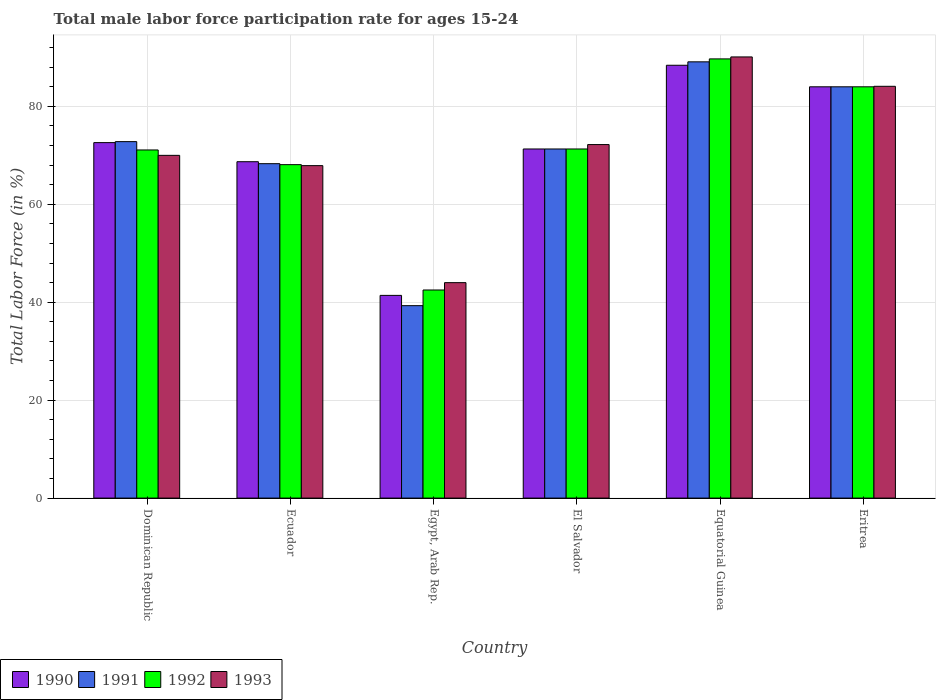How many different coloured bars are there?
Make the answer very short. 4. Are the number of bars per tick equal to the number of legend labels?
Offer a terse response. Yes. How many bars are there on the 3rd tick from the right?
Your answer should be very brief. 4. What is the label of the 6th group of bars from the left?
Your response must be concise. Eritrea. What is the male labor force participation rate in 1990 in El Salvador?
Ensure brevity in your answer.  71.3. Across all countries, what is the maximum male labor force participation rate in 1990?
Your answer should be very brief. 88.4. In which country was the male labor force participation rate in 1990 maximum?
Your answer should be compact. Equatorial Guinea. In which country was the male labor force participation rate in 1991 minimum?
Provide a succinct answer. Egypt, Arab Rep. What is the total male labor force participation rate in 1992 in the graph?
Your answer should be very brief. 426.7. What is the difference between the male labor force participation rate in 1990 in El Salvador and that in Eritrea?
Make the answer very short. -12.7. What is the average male labor force participation rate in 1991 per country?
Offer a terse response. 70.8. What is the difference between the male labor force participation rate of/in 1993 and male labor force participation rate of/in 1992 in Dominican Republic?
Offer a terse response. -1.1. What is the ratio of the male labor force participation rate in 1991 in Dominican Republic to that in El Salvador?
Your answer should be very brief. 1.02. Is the difference between the male labor force participation rate in 1993 in Dominican Republic and El Salvador greater than the difference between the male labor force participation rate in 1992 in Dominican Republic and El Salvador?
Ensure brevity in your answer.  No. What is the difference between the highest and the second highest male labor force participation rate in 1991?
Provide a short and direct response. -16.3. What is the difference between the highest and the lowest male labor force participation rate in 1992?
Your answer should be very brief. 47.2. In how many countries, is the male labor force participation rate in 1990 greater than the average male labor force participation rate in 1990 taken over all countries?
Your response must be concise. 4. Is it the case that in every country, the sum of the male labor force participation rate in 1993 and male labor force participation rate in 1992 is greater than the sum of male labor force participation rate in 1991 and male labor force participation rate in 1990?
Give a very brief answer. No. What does the 3rd bar from the right in Dominican Republic represents?
Offer a very short reply. 1991. Is it the case that in every country, the sum of the male labor force participation rate in 1992 and male labor force participation rate in 1993 is greater than the male labor force participation rate in 1991?
Your response must be concise. Yes. How many bars are there?
Give a very brief answer. 24. What is the difference between two consecutive major ticks on the Y-axis?
Provide a short and direct response. 20. Are the values on the major ticks of Y-axis written in scientific E-notation?
Make the answer very short. No. Does the graph contain grids?
Provide a short and direct response. Yes. Where does the legend appear in the graph?
Your response must be concise. Bottom left. How many legend labels are there?
Offer a terse response. 4. What is the title of the graph?
Give a very brief answer. Total male labor force participation rate for ages 15-24. Does "2013" appear as one of the legend labels in the graph?
Provide a short and direct response. No. What is the Total Labor Force (in %) in 1990 in Dominican Republic?
Provide a succinct answer. 72.6. What is the Total Labor Force (in %) of 1991 in Dominican Republic?
Keep it short and to the point. 72.8. What is the Total Labor Force (in %) of 1992 in Dominican Republic?
Provide a succinct answer. 71.1. What is the Total Labor Force (in %) in 1990 in Ecuador?
Ensure brevity in your answer.  68.7. What is the Total Labor Force (in %) in 1991 in Ecuador?
Provide a short and direct response. 68.3. What is the Total Labor Force (in %) in 1992 in Ecuador?
Offer a very short reply. 68.1. What is the Total Labor Force (in %) in 1993 in Ecuador?
Provide a short and direct response. 67.9. What is the Total Labor Force (in %) in 1990 in Egypt, Arab Rep.?
Provide a succinct answer. 41.4. What is the Total Labor Force (in %) of 1991 in Egypt, Arab Rep.?
Offer a terse response. 39.3. What is the Total Labor Force (in %) of 1992 in Egypt, Arab Rep.?
Offer a very short reply. 42.5. What is the Total Labor Force (in %) of 1993 in Egypt, Arab Rep.?
Keep it short and to the point. 44. What is the Total Labor Force (in %) of 1990 in El Salvador?
Offer a very short reply. 71.3. What is the Total Labor Force (in %) in 1991 in El Salvador?
Ensure brevity in your answer.  71.3. What is the Total Labor Force (in %) in 1992 in El Salvador?
Offer a very short reply. 71.3. What is the Total Labor Force (in %) in 1993 in El Salvador?
Your answer should be compact. 72.2. What is the Total Labor Force (in %) in 1990 in Equatorial Guinea?
Your response must be concise. 88.4. What is the Total Labor Force (in %) of 1991 in Equatorial Guinea?
Your response must be concise. 89.1. What is the Total Labor Force (in %) of 1992 in Equatorial Guinea?
Your answer should be very brief. 89.7. What is the Total Labor Force (in %) in 1993 in Equatorial Guinea?
Your answer should be very brief. 90.1. What is the Total Labor Force (in %) in 1991 in Eritrea?
Your answer should be very brief. 84. What is the Total Labor Force (in %) in 1993 in Eritrea?
Your answer should be compact. 84.1. Across all countries, what is the maximum Total Labor Force (in %) in 1990?
Give a very brief answer. 88.4. Across all countries, what is the maximum Total Labor Force (in %) of 1991?
Your response must be concise. 89.1. Across all countries, what is the maximum Total Labor Force (in %) in 1992?
Keep it short and to the point. 89.7. Across all countries, what is the maximum Total Labor Force (in %) in 1993?
Your answer should be compact. 90.1. Across all countries, what is the minimum Total Labor Force (in %) in 1990?
Provide a short and direct response. 41.4. Across all countries, what is the minimum Total Labor Force (in %) in 1991?
Provide a succinct answer. 39.3. Across all countries, what is the minimum Total Labor Force (in %) in 1992?
Your answer should be very brief. 42.5. What is the total Total Labor Force (in %) of 1990 in the graph?
Keep it short and to the point. 426.4. What is the total Total Labor Force (in %) in 1991 in the graph?
Provide a succinct answer. 424.8. What is the total Total Labor Force (in %) of 1992 in the graph?
Ensure brevity in your answer.  426.7. What is the total Total Labor Force (in %) of 1993 in the graph?
Your answer should be compact. 428.3. What is the difference between the Total Labor Force (in %) in 1990 in Dominican Republic and that in Ecuador?
Give a very brief answer. 3.9. What is the difference between the Total Labor Force (in %) in 1990 in Dominican Republic and that in Egypt, Arab Rep.?
Provide a succinct answer. 31.2. What is the difference between the Total Labor Force (in %) in 1991 in Dominican Republic and that in Egypt, Arab Rep.?
Provide a short and direct response. 33.5. What is the difference between the Total Labor Force (in %) in 1992 in Dominican Republic and that in Egypt, Arab Rep.?
Keep it short and to the point. 28.6. What is the difference between the Total Labor Force (in %) in 1993 in Dominican Republic and that in Egypt, Arab Rep.?
Provide a succinct answer. 26. What is the difference between the Total Labor Force (in %) of 1990 in Dominican Republic and that in El Salvador?
Keep it short and to the point. 1.3. What is the difference between the Total Labor Force (in %) of 1992 in Dominican Republic and that in El Salvador?
Ensure brevity in your answer.  -0.2. What is the difference between the Total Labor Force (in %) in 1990 in Dominican Republic and that in Equatorial Guinea?
Your answer should be compact. -15.8. What is the difference between the Total Labor Force (in %) of 1991 in Dominican Republic and that in Equatorial Guinea?
Ensure brevity in your answer.  -16.3. What is the difference between the Total Labor Force (in %) in 1992 in Dominican Republic and that in Equatorial Guinea?
Offer a very short reply. -18.6. What is the difference between the Total Labor Force (in %) in 1993 in Dominican Republic and that in Equatorial Guinea?
Your answer should be very brief. -20.1. What is the difference between the Total Labor Force (in %) of 1991 in Dominican Republic and that in Eritrea?
Give a very brief answer. -11.2. What is the difference between the Total Labor Force (in %) of 1993 in Dominican Republic and that in Eritrea?
Your answer should be compact. -14.1. What is the difference between the Total Labor Force (in %) in 1990 in Ecuador and that in Egypt, Arab Rep.?
Your response must be concise. 27.3. What is the difference between the Total Labor Force (in %) in 1992 in Ecuador and that in Egypt, Arab Rep.?
Make the answer very short. 25.6. What is the difference between the Total Labor Force (in %) in 1993 in Ecuador and that in Egypt, Arab Rep.?
Ensure brevity in your answer.  23.9. What is the difference between the Total Labor Force (in %) of 1991 in Ecuador and that in El Salvador?
Give a very brief answer. -3. What is the difference between the Total Labor Force (in %) in 1993 in Ecuador and that in El Salvador?
Give a very brief answer. -4.3. What is the difference between the Total Labor Force (in %) of 1990 in Ecuador and that in Equatorial Guinea?
Your answer should be very brief. -19.7. What is the difference between the Total Labor Force (in %) in 1991 in Ecuador and that in Equatorial Guinea?
Offer a terse response. -20.8. What is the difference between the Total Labor Force (in %) of 1992 in Ecuador and that in Equatorial Guinea?
Ensure brevity in your answer.  -21.6. What is the difference between the Total Labor Force (in %) of 1993 in Ecuador and that in Equatorial Guinea?
Provide a short and direct response. -22.2. What is the difference between the Total Labor Force (in %) of 1990 in Ecuador and that in Eritrea?
Your answer should be very brief. -15.3. What is the difference between the Total Labor Force (in %) of 1991 in Ecuador and that in Eritrea?
Keep it short and to the point. -15.7. What is the difference between the Total Labor Force (in %) of 1992 in Ecuador and that in Eritrea?
Provide a short and direct response. -15.9. What is the difference between the Total Labor Force (in %) in 1993 in Ecuador and that in Eritrea?
Your answer should be very brief. -16.2. What is the difference between the Total Labor Force (in %) of 1990 in Egypt, Arab Rep. and that in El Salvador?
Make the answer very short. -29.9. What is the difference between the Total Labor Force (in %) in 1991 in Egypt, Arab Rep. and that in El Salvador?
Provide a short and direct response. -32. What is the difference between the Total Labor Force (in %) in 1992 in Egypt, Arab Rep. and that in El Salvador?
Ensure brevity in your answer.  -28.8. What is the difference between the Total Labor Force (in %) of 1993 in Egypt, Arab Rep. and that in El Salvador?
Provide a short and direct response. -28.2. What is the difference between the Total Labor Force (in %) of 1990 in Egypt, Arab Rep. and that in Equatorial Guinea?
Your answer should be compact. -47. What is the difference between the Total Labor Force (in %) in 1991 in Egypt, Arab Rep. and that in Equatorial Guinea?
Provide a succinct answer. -49.8. What is the difference between the Total Labor Force (in %) in 1992 in Egypt, Arab Rep. and that in Equatorial Guinea?
Provide a succinct answer. -47.2. What is the difference between the Total Labor Force (in %) of 1993 in Egypt, Arab Rep. and that in Equatorial Guinea?
Offer a terse response. -46.1. What is the difference between the Total Labor Force (in %) in 1990 in Egypt, Arab Rep. and that in Eritrea?
Offer a terse response. -42.6. What is the difference between the Total Labor Force (in %) in 1991 in Egypt, Arab Rep. and that in Eritrea?
Make the answer very short. -44.7. What is the difference between the Total Labor Force (in %) of 1992 in Egypt, Arab Rep. and that in Eritrea?
Your answer should be compact. -41.5. What is the difference between the Total Labor Force (in %) of 1993 in Egypt, Arab Rep. and that in Eritrea?
Make the answer very short. -40.1. What is the difference between the Total Labor Force (in %) in 1990 in El Salvador and that in Equatorial Guinea?
Provide a short and direct response. -17.1. What is the difference between the Total Labor Force (in %) of 1991 in El Salvador and that in Equatorial Guinea?
Keep it short and to the point. -17.8. What is the difference between the Total Labor Force (in %) of 1992 in El Salvador and that in Equatorial Guinea?
Make the answer very short. -18.4. What is the difference between the Total Labor Force (in %) of 1993 in El Salvador and that in Equatorial Guinea?
Keep it short and to the point. -17.9. What is the difference between the Total Labor Force (in %) of 1990 in El Salvador and that in Eritrea?
Ensure brevity in your answer.  -12.7. What is the difference between the Total Labor Force (in %) in 1992 in El Salvador and that in Eritrea?
Offer a terse response. -12.7. What is the difference between the Total Labor Force (in %) in 1993 in El Salvador and that in Eritrea?
Provide a succinct answer. -11.9. What is the difference between the Total Labor Force (in %) of 1990 in Equatorial Guinea and that in Eritrea?
Offer a very short reply. 4.4. What is the difference between the Total Labor Force (in %) of 1991 in Equatorial Guinea and that in Eritrea?
Your response must be concise. 5.1. What is the difference between the Total Labor Force (in %) of 1993 in Equatorial Guinea and that in Eritrea?
Make the answer very short. 6. What is the difference between the Total Labor Force (in %) of 1990 in Dominican Republic and the Total Labor Force (in %) of 1991 in Ecuador?
Offer a terse response. 4.3. What is the difference between the Total Labor Force (in %) in 1990 in Dominican Republic and the Total Labor Force (in %) in 1993 in Ecuador?
Keep it short and to the point. 4.7. What is the difference between the Total Labor Force (in %) in 1991 in Dominican Republic and the Total Labor Force (in %) in 1993 in Ecuador?
Make the answer very short. 4.9. What is the difference between the Total Labor Force (in %) of 1992 in Dominican Republic and the Total Labor Force (in %) of 1993 in Ecuador?
Your response must be concise. 3.2. What is the difference between the Total Labor Force (in %) of 1990 in Dominican Republic and the Total Labor Force (in %) of 1991 in Egypt, Arab Rep.?
Keep it short and to the point. 33.3. What is the difference between the Total Labor Force (in %) in 1990 in Dominican Republic and the Total Labor Force (in %) in 1992 in Egypt, Arab Rep.?
Ensure brevity in your answer.  30.1. What is the difference between the Total Labor Force (in %) of 1990 in Dominican Republic and the Total Labor Force (in %) of 1993 in Egypt, Arab Rep.?
Keep it short and to the point. 28.6. What is the difference between the Total Labor Force (in %) in 1991 in Dominican Republic and the Total Labor Force (in %) in 1992 in Egypt, Arab Rep.?
Your answer should be very brief. 30.3. What is the difference between the Total Labor Force (in %) in 1991 in Dominican Republic and the Total Labor Force (in %) in 1993 in Egypt, Arab Rep.?
Your answer should be compact. 28.8. What is the difference between the Total Labor Force (in %) in 1992 in Dominican Republic and the Total Labor Force (in %) in 1993 in Egypt, Arab Rep.?
Your response must be concise. 27.1. What is the difference between the Total Labor Force (in %) in 1990 in Dominican Republic and the Total Labor Force (in %) in 1991 in El Salvador?
Provide a short and direct response. 1.3. What is the difference between the Total Labor Force (in %) in 1991 in Dominican Republic and the Total Labor Force (in %) in 1993 in El Salvador?
Give a very brief answer. 0.6. What is the difference between the Total Labor Force (in %) in 1992 in Dominican Republic and the Total Labor Force (in %) in 1993 in El Salvador?
Ensure brevity in your answer.  -1.1. What is the difference between the Total Labor Force (in %) in 1990 in Dominican Republic and the Total Labor Force (in %) in 1991 in Equatorial Guinea?
Your response must be concise. -16.5. What is the difference between the Total Labor Force (in %) of 1990 in Dominican Republic and the Total Labor Force (in %) of 1992 in Equatorial Guinea?
Provide a short and direct response. -17.1. What is the difference between the Total Labor Force (in %) of 1990 in Dominican Republic and the Total Labor Force (in %) of 1993 in Equatorial Guinea?
Make the answer very short. -17.5. What is the difference between the Total Labor Force (in %) of 1991 in Dominican Republic and the Total Labor Force (in %) of 1992 in Equatorial Guinea?
Ensure brevity in your answer.  -16.9. What is the difference between the Total Labor Force (in %) of 1991 in Dominican Republic and the Total Labor Force (in %) of 1993 in Equatorial Guinea?
Provide a short and direct response. -17.3. What is the difference between the Total Labor Force (in %) in 1991 in Dominican Republic and the Total Labor Force (in %) in 1992 in Eritrea?
Provide a short and direct response. -11.2. What is the difference between the Total Labor Force (in %) of 1992 in Dominican Republic and the Total Labor Force (in %) of 1993 in Eritrea?
Make the answer very short. -13. What is the difference between the Total Labor Force (in %) of 1990 in Ecuador and the Total Labor Force (in %) of 1991 in Egypt, Arab Rep.?
Make the answer very short. 29.4. What is the difference between the Total Labor Force (in %) in 1990 in Ecuador and the Total Labor Force (in %) in 1992 in Egypt, Arab Rep.?
Your answer should be very brief. 26.2. What is the difference between the Total Labor Force (in %) in 1990 in Ecuador and the Total Labor Force (in %) in 1993 in Egypt, Arab Rep.?
Your response must be concise. 24.7. What is the difference between the Total Labor Force (in %) in 1991 in Ecuador and the Total Labor Force (in %) in 1992 in Egypt, Arab Rep.?
Keep it short and to the point. 25.8. What is the difference between the Total Labor Force (in %) in 1991 in Ecuador and the Total Labor Force (in %) in 1993 in Egypt, Arab Rep.?
Your answer should be compact. 24.3. What is the difference between the Total Labor Force (in %) in 1992 in Ecuador and the Total Labor Force (in %) in 1993 in Egypt, Arab Rep.?
Keep it short and to the point. 24.1. What is the difference between the Total Labor Force (in %) of 1990 in Ecuador and the Total Labor Force (in %) of 1991 in El Salvador?
Make the answer very short. -2.6. What is the difference between the Total Labor Force (in %) of 1990 in Ecuador and the Total Labor Force (in %) of 1993 in El Salvador?
Offer a terse response. -3.5. What is the difference between the Total Labor Force (in %) in 1991 in Ecuador and the Total Labor Force (in %) in 1992 in El Salvador?
Your answer should be very brief. -3. What is the difference between the Total Labor Force (in %) in 1990 in Ecuador and the Total Labor Force (in %) in 1991 in Equatorial Guinea?
Offer a very short reply. -20.4. What is the difference between the Total Labor Force (in %) in 1990 in Ecuador and the Total Labor Force (in %) in 1992 in Equatorial Guinea?
Your answer should be compact. -21. What is the difference between the Total Labor Force (in %) of 1990 in Ecuador and the Total Labor Force (in %) of 1993 in Equatorial Guinea?
Give a very brief answer. -21.4. What is the difference between the Total Labor Force (in %) in 1991 in Ecuador and the Total Labor Force (in %) in 1992 in Equatorial Guinea?
Offer a very short reply. -21.4. What is the difference between the Total Labor Force (in %) of 1991 in Ecuador and the Total Labor Force (in %) of 1993 in Equatorial Guinea?
Offer a terse response. -21.8. What is the difference between the Total Labor Force (in %) in 1992 in Ecuador and the Total Labor Force (in %) in 1993 in Equatorial Guinea?
Provide a succinct answer. -22. What is the difference between the Total Labor Force (in %) of 1990 in Ecuador and the Total Labor Force (in %) of 1991 in Eritrea?
Offer a terse response. -15.3. What is the difference between the Total Labor Force (in %) of 1990 in Ecuador and the Total Labor Force (in %) of 1992 in Eritrea?
Keep it short and to the point. -15.3. What is the difference between the Total Labor Force (in %) in 1990 in Ecuador and the Total Labor Force (in %) in 1993 in Eritrea?
Give a very brief answer. -15.4. What is the difference between the Total Labor Force (in %) in 1991 in Ecuador and the Total Labor Force (in %) in 1992 in Eritrea?
Your answer should be compact. -15.7. What is the difference between the Total Labor Force (in %) of 1991 in Ecuador and the Total Labor Force (in %) of 1993 in Eritrea?
Your response must be concise. -15.8. What is the difference between the Total Labor Force (in %) in 1990 in Egypt, Arab Rep. and the Total Labor Force (in %) in 1991 in El Salvador?
Provide a short and direct response. -29.9. What is the difference between the Total Labor Force (in %) in 1990 in Egypt, Arab Rep. and the Total Labor Force (in %) in 1992 in El Salvador?
Your answer should be very brief. -29.9. What is the difference between the Total Labor Force (in %) in 1990 in Egypt, Arab Rep. and the Total Labor Force (in %) in 1993 in El Salvador?
Make the answer very short. -30.8. What is the difference between the Total Labor Force (in %) of 1991 in Egypt, Arab Rep. and the Total Labor Force (in %) of 1992 in El Salvador?
Provide a short and direct response. -32. What is the difference between the Total Labor Force (in %) in 1991 in Egypt, Arab Rep. and the Total Labor Force (in %) in 1993 in El Salvador?
Your answer should be compact. -32.9. What is the difference between the Total Labor Force (in %) in 1992 in Egypt, Arab Rep. and the Total Labor Force (in %) in 1993 in El Salvador?
Offer a terse response. -29.7. What is the difference between the Total Labor Force (in %) of 1990 in Egypt, Arab Rep. and the Total Labor Force (in %) of 1991 in Equatorial Guinea?
Offer a terse response. -47.7. What is the difference between the Total Labor Force (in %) in 1990 in Egypt, Arab Rep. and the Total Labor Force (in %) in 1992 in Equatorial Guinea?
Offer a very short reply. -48.3. What is the difference between the Total Labor Force (in %) of 1990 in Egypt, Arab Rep. and the Total Labor Force (in %) of 1993 in Equatorial Guinea?
Offer a terse response. -48.7. What is the difference between the Total Labor Force (in %) in 1991 in Egypt, Arab Rep. and the Total Labor Force (in %) in 1992 in Equatorial Guinea?
Offer a terse response. -50.4. What is the difference between the Total Labor Force (in %) in 1991 in Egypt, Arab Rep. and the Total Labor Force (in %) in 1993 in Equatorial Guinea?
Make the answer very short. -50.8. What is the difference between the Total Labor Force (in %) in 1992 in Egypt, Arab Rep. and the Total Labor Force (in %) in 1993 in Equatorial Guinea?
Keep it short and to the point. -47.6. What is the difference between the Total Labor Force (in %) of 1990 in Egypt, Arab Rep. and the Total Labor Force (in %) of 1991 in Eritrea?
Your answer should be very brief. -42.6. What is the difference between the Total Labor Force (in %) in 1990 in Egypt, Arab Rep. and the Total Labor Force (in %) in 1992 in Eritrea?
Your answer should be very brief. -42.6. What is the difference between the Total Labor Force (in %) of 1990 in Egypt, Arab Rep. and the Total Labor Force (in %) of 1993 in Eritrea?
Ensure brevity in your answer.  -42.7. What is the difference between the Total Labor Force (in %) of 1991 in Egypt, Arab Rep. and the Total Labor Force (in %) of 1992 in Eritrea?
Give a very brief answer. -44.7. What is the difference between the Total Labor Force (in %) in 1991 in Egypt, Arab Rep. and the Total Labor Force (in %) in 1993 in Eritrea?
Provide a short and direct response. -44.8. What is the difference between the Total Labor Force (in %) of 1992 in Egypt, Arab Rep. and the Total Labor Force (in %) of 1993 in Eritrea?
Ensure brevity in your answer.  -41.6. What is the difference between the Total Labor Force (in %) of 1990 in El Salvador and the Total Labor Force (in %) of 1991 in Equatorial Guinea?
Ensure brevity in your answer.  -17.8. What is the difference between the Total Labor Force (in %) of 1990 in El Salvador and the Total Labor Force (in %) of 1992 in Equatorial Guinea?
Offer a terse response. -18.4. What is the difference between the Total Labor Force (in %) in 1990 in El Salvador and the Total Labor Force (in %) in 1993 in Equatorial Guinea?
Provide a short and direct response. -18.8. What is the difference between the Total Labor Force (in %) of 1991 in El Salvador and the Total Labor Force (in %) of 1992 in Equatorial Guinea?
Your answer should be very brief. -18.4. What is the difference between the Total Labor Force (in %) in 1991 in El Salvador and the Total Labor Force (in %) in 1993 in Equatorial Guinea?
Your answer should be compact. -18.8. What is the difference between the Total Labor Force (in %) in 1992 in El Salvador and the Total Labor Force (in %) in 1993 in Equatorial Guinea?
Give a very brief answer. -18.8. What is the difference between the Total Labor Force (in %) in 1990 in El Salvador and the Total Labor Force (in %) in 1992 in Eritrea?
Ensure brevity in your answer.  -12.7. What is the difference between the Total Labor Force (in %) of 1991 in El Salvador and the Total Labor Force (in %) of 1993 in Eritrea?
Give a very brief answer. -12.8. What is the difference between the Total Labor Force (in %) of 1990 in Equatorial Guinea and the Total Labor Force (in %) of 1992 in Eritrea?
Offer a very short reply. 4.4. What is the difference between the Total Labor Force (in %) in 1990 in Equatorial Guinea and the Total Labor Force (in %) in 1993 in Eritrea?
Your answer should be very brief. 4.3. What is the difference between the Total Labor Force (in %) in 1991 in Equatorial Guinea and the Total Labor Force (in %) in 1993 in Eritrea?
Offer a very short reply. 5. What is the average Total Labor Force (in %) in 1990 per country?
Your answer should be very brief. 71.07. What is the average Total Labor Force (in %) in 1991 per country?
Offer a very short reply. 70.8. What is the average Total Labor Force (in %) of 1992 per country?
Make the answer very short. 71.12. What is the average Total Labor Force (in %) of 1993 per country?
Provide a short and direct response. 71.38. What is the difference between the Total Labor Force (in %) of 1990 and Total Labor Force (in %) of 1992 in Dominican Republic?
Your response must be concise. 1.5. What is the difference between the Total Labor Force (in %) of 1991 and Total Labor Force (in %) of 1992 in Dominican Republic?
Make the answer very short. 1.7. What is the difference between the Total Labor Force (in %) in 1991 and Total Labor Force (in %) in 1993 in Dominican Republic?
Make the answer very short. 2.8. What is the difference between the Total Labor Force (in %) in 1990 and Total Labor Force (in %) in 1991 in Ecuador?
Keep it short and to the point. 0.4. What is the difference between the Total Labor Force (in %) in 1991 and Total Labor Force (in %) in 1992 in Ecuador?
Your response must be concise. 0.2. What is the difference between the Total Labor Force (in %) of 1992 and Total Labor Force (in %) of 1993 in Ecuador?
Make the answer very short. 0.2. What is the difference between the Total Labor Force (in %) in 1990 and Total Labor Force (in %) in 1991 in Egypt, Arab Rep.?
Your response must be concise. 2.1. What is the difference between the Total Labor Force (in %) in 1990 and Total Labor Force (in %) in 1992 in Egypt, Arab Rep.?
Keep it short and to the point. -1.1. What is the difference between the Total Labor Force (in %) of 1990 and Total Labor Force (in %) of 1993 in Egypt, Arab Rep.?
Provide a succinct answer. -2.6. What is the difference between the Total Labor Force (in %) in 1991 and Total Labor Force (in %) in 1992 in Egypt, Arab Rep.?
Your answer should be compact. -3.2. What is the difference between the Total Labor Force (in %) in 1990 and Total Labor Force (in %) in 1991 in El Salvador?
Your answer should be very brief. 0. What is the difference between the Total Labor Force (in %) of 1990 and Total Labor Force (in %) of 1992 in El Salvador?
Provide a short and direct response. 0. What is the difference between the Total Labor Force (in %) of 1990 and Total Labor Force (in %) of 1993 in El Salvador?
Make the answer very short. -0.9. What is the difference between the Total Labor Force (in %) of 1991 and Total Labor Force (in %) of 1993 in El Salvador?
Provide a short and direct response. -0.9. What is the difference between the Total Labor Force (in %) in 1992 and Total Labor Force (in %) in 1993 in El Salvador?
Your answer should be compact. -0.9. What is the difference between the Total Labor Force (in %) in 1990 and Total Labor Force (in %) in 1991 in Equatorial Guinea?
Provide a succinct answer. -0.7. What is the difference between the Total Labor Force (in %) in 1990 and Total Labor Force (in %) in 1992 in Equatorial Guinea?
Your response must be concise. -1.3. What is the difference between the Total Labor Force (in %) in 1991 and Total Labor Force (in %) in 1993 in Equatorial Guinea?
Keep it short and to the point. -1. What is the difference between the Total Labor Force (in %) in 1990 and Total Labor Force (in %) in 1993 in Eritrea?
Make the answer very short. -0.1. What is the difference between the Total Labor Force (in %) of 1992 and Total Labor Force (in %) of 1993 in Eritrea?
Give a very brief answer. -0.1. What is the ratio of the Total Labor Force (in %) of 1990 in Dominican Republic to that in Ecuador?
Keep it short and to the point. 1.06. What is the ratio of the Total Labor Force (in %) in 1991 in Dominican Republic to that in Ecuador?
Provide a short and direct response. 1.07. What is the ratio of the Total Labor Force (in %) of 1992 in Dominican Republic to that in Ecuador?
Give a very brief answer. 1.04. What is the ratio of the Total Labor Force (in %) in 1993 in Dominican Republic to that in Ecuador?
Provide a succinct answer. 1.03. What is the ratio of the Total Labor Force (in %) in 1990 in Dominican Republic to that in Egypt, Arab Rep.?
Provide a succinct answer. 1.75. What is the ratio of the Total Labor Force (in %) in 1991 in Dominican Republic to that in Egypt, Arab Rep.?
Make the answer very short. 1.85. What is the ratio of the Total Labor Force (in %) in 1992 in Dominican Republic to that in Egypt, Arab Rep.?
Provide a short and direct response. 1.67. What is the ratio of the Total Labor Force (in %) of 1993 in Dominican Republic to that in Egypt, Arab Rep.?
Your response must be concise. 1.59. What is the ratio of the Total Labor Force (in %) of 1990 in Dominican Republic to that in El Salvador?
Make the answer very short. 1.02. What is the ratio of the Total Labor Force (in %) of 1991 in Dominican Republic to that in El Salvador?
Provide a succinct answer. 1.02. What is the ratio of the Total Labor Force (in %) in 1992 in Dominican Republic to that in El Salvador?
Your answer should be very brief. 1. What is the ratio of the Total Labor Force (in %) of 1993 in Dominican Republic to that in El Salvador?
Provide a succinct answer. 0.97. What is the ratio of the Total Labor Force (in %) of 1990 in Dominican Republic to that in Equatorial Guinea?
Provide a succinct answer. 0.82. What is the ratio of the Total Labor Force (in %) of 1991 in Dominican Republic to that in Equatorial Guinea?
Your response must be concise. 0.82. What is the ratio of the Total Labor Force (in %) of 1992 in Dominican Republic to that in Equatorial Guinea?
Your answer should be very brief. 0.79. What is the ratio of the Total Labor Force (in %) in 1993 in Dominican Republic to that in Equatorial Guinea?
Give a very brief answer. 0.78. What is the ratio of the Total Labor Force (in %) of 1990 in Dominican Republic to that in Eritrea?
Ensure brevity in your answer.  0.86. What is the ratio of the Total Labor Force (in %) in 1991 in Dominican Republic to that in Eritrea?
Your answer should be compact. 0.87. What is the ratio of the Total Labor Force (in %) of 1992 in Dominican Republic to that in Eritrea?
Give a very brief answer. 0.85. What is the ratio of the Total Labor Force (in %) of 1993 in Dominican Republic to that in Eritrea?
Keep it short and to the point. 0.83. What is the ratio of the Total Labor Force (in %) in 1990 in Ecuador to that in Egypt, Arab Rep.?
Ensure brevity in your answer.  1.66. What is the ratio of the Total Labor Force (in %) of 1991 in Ecuador to that in Egypt, Arab Rep.?
Make the answer very short. 1.74. What is the ratio of the Total Labor Force (in %) in 1992 in Ecuador to that in Egypt, Arab Rep.?
Offer a terse response. 1.6. What is the ratio of the Total Labor Force (in %) in 1993 in Ecuador to that in Egypt, Arab Rep.?
Ensure brevity in your answer.  1.54. What is the ratio of the Total Labor Force (in %) in 1990 in Ecuador to that in El Salvador?
Provide a succinct answer. 0.96. What is the ratio of the Total Labor Force (in %) of 1991 in Ecuador to that in El Salvador?
Give a very brief answer. 0.96. What is the ratio of the Total Labor Force (in %) in 1992 in Ecuador to that in El Salvador?
Your response must be concise. 0.96. What is the ratio of the Total Labor Force (in %) of 1993 in Ecuador to that in El Salvador?
Offer a terse response. 0.94. What is the ratio of the Total Labor Force (in %) of 1990 in Ecuador to that in Equatorial Guinea?
Your answer should be very brief. 0.78. What is the ratio of the Total Labor Force (in %) of 1991 in Ecuador to that in Equatorial Guinea?
Provide a succinct answer. 0.77. What is the ratio of the Total Labor Force (in %) of 1992 in Ecuador to that in Equatorial Guinea?
Keep it short and to the point. 0.76. What is the ratio of the Total Labor Force (in %) of 1993 in Ecuador to that in Equatorial Guinea?
Provide a short and direct response. 0.75. What is the ratio of the Total Labor Force (in %) in 1990 in Ecuador to that in Eritrea?
Your answer should be very brief. 0.82. What is the ratio of the Total Labor Force (in %) of 1991 in Ecuador to that in Eritrea?
Ensure brevity in your answer.  0.81. What is the ratio of the Total Labor Force (in %) in 1992 in Ecuador to that in Eritrea?
Offer a terse response. 0.81. What is the ratio of the Total Labor Force (in %) in 1993 in Ecuador to that in Eritrea?
Give a very brief answer. 0.81. What is the ratio of the Total Labor Force (in %) in 1990 in Egypt, Arab Rep. to that in El Salvador?
Make the answer very short. 0.58. What is the ratio of the Total Labor Force (in %) in 1991 in Egypt, Arab Rep. to that in El Salvador?
Provide a succinct answer. 0.55. What is the ratio of the Total Labor Force (in %) of 1992 in Egypt, Arab Rep. to that in El Salvador?
Offer a terse response. 0.6. What is the ratio of the Total Labor Force (in %) of 1993 in Egypt, Arab Rep. to that in El Salvador?
Provide a succinct answer. 0.61. What is the ratio of the Total Labor Force (in %) in 1990 in Egypt, Arab Rep. to that in Equatorial Guinea?
Ensure brevity in your answer.  0.47. What is the ratio of the Total Labor Force (in %) of 1991 in Egypt, Arab Rep. to that in Equatorial Guinea?
Give a very brief answer. 0.44. What is the ratio of the Total Labor Force (in %) of 1992 in Egypt, Arab Rep. to that in Equatorial Guinea?
Give a very brief answer. 0.47. What is the ratio of the Total Labor Force (in %) of 1993 in Egypt, Arab Rep. to that in Equatorial Guinea?
Offer a terse response. 0.49. What is the ratio of the Total Labor Force (in %) in 1990 in Egypt, Arab Rep. to that in Eritrea?
Your response must be concise. 0.49. What is the ratio of the Total Labor Force (in %) in 1991 in Egypt, Arab Rep. to that in Eritrea?
Your answer should be compact. 0.47. What is the ratio of the Total Labor Force (in %) of 1992 in Egypt, Arab Rep. to that in Eritrea?
Provide a short and direct response. 0.51. What is the ratio of the Total Labor Force (in %) in 1993 in Egypt, Arab Rep. to that in Eritrea?
Provide a short and direct response. 0.52. What is the ratio of the Total Labor Force (in %) of 1990 in El Salvador to that in Equatorial Guinea?
Your response must be concise. 0.81. What is the ratio of the Total Labor Force (in %) in 1991 in El Salvador to that in Equatorial Guinea?
Your answer should be compact. 0.8. What is the ratio of the Total Labor Force (in %) of 1992 in El Salvador to that in Equatorial Guinea?
Your response must be concise. 0.79. What is the ratio of the Total Labor Force (in %) of 1993 in El Salvador to that in Equatorial Guinea?
Offer a very short reply. 0.8. What is the ratio of the Total Labor Force (in %) in 1990 in El Salvador to that in Eritrea?
Provide a short and direct response. 0.85. What is the ratio of the Total Labor Force (in %) of 1991 in El Salvador to that in Eritrea?
Your answer should be compact. 0.85. What is the ratio of the Total Labor Force (in %) in 1992 in El Salvador to that in Eritrea?
Offer a very short reply. 0.85. What is the ratio of the Total Labor Force (in %) in 1993 in El Salvador to that in Eritrea?
Offer a very short reply. 0.86. What is the ratio of the Total Labor Force (in %) in 1990 in Equatorial Guinea to that in Eritrea?
Keep it short and to the point. 1.05. What is the ratio of the Total Labor Force (in %) in 1991 in Equatorial Guinea to that in Eritrea?
Your answer should be compact. 1.06. What is the ratio of the Total Labor Force (in %) in 1992 in Equatorial Guinea to that in Eritrea?
Provide a short and direct response. 1.07. What is the ratio of the Total Labor Force (in %) of 1993 in Equatorial Guinea to that in Eritrea?
Provide a short and direct response. 1.07. What is the difference between the highest and the second highest Total Labor Force (in %) in 1991?
Your answer should be very brief. 5.1. What is the difference between the highest and the lowest Total Labor Force (in %) in 1990?
Offer a very short reply. 47. What is the difference between the highest and the lowest Total Labor Force (in %) in 1991?
Your answer should be very brief. 49.8. What is the difference between the highest and the lowest Total Labor Force (in %) of 1992?
Offer a very short reply. 47.2. What is the difference between the highest and the lowest Total Labor Force (in %) of 1993?
Your response must be concise. 46.1. 